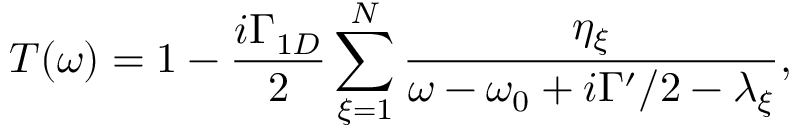Convert formula to latex. <formula><loc_0><loc_0><loc_500><loc_500>T ( \omega ) = 1 - \frac { i \Gamma _ { 1 D } } { 2 } \sum _ { \xi = 1 } ^ { N } \frac { \eta _ { \xi } } { \omega - \omega _ { 0 } + i \Gamma ^ { \prime } / 2 - \lambda _ { \xi } } ,</formula> 